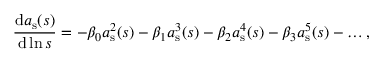Convert formula to latex. <formula><loc_0><loc_0><loc_500><loc_500>\frac { d a _ { s } ( s ) } { d \ln s } = - \beta _ { 0 } a _ { s } ^ { 2 } ( s ) - \beta _ { 1 } a _ { s } ^ { 3 } ( s ) - \beta _ { 2 } a _ { s } ^ { 4 } ( s ) - \beta _ { 3 } a _ { s } ^ { 5 } ( s ) - \dots ,</formula> 